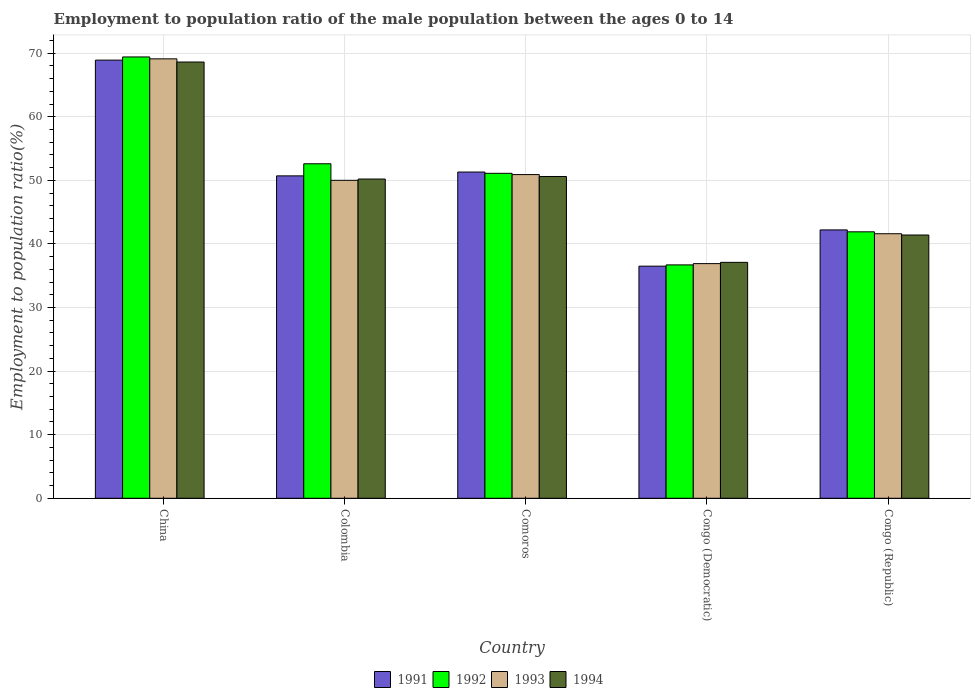How many different coloured bars are there?
Make the answer very short. 4. Are the number of bars on each tick of the X-axis equal?
Your answer should be very brief. Yes. How many bars are there on the 4th tick from the right?
Give a very brief answer. 4. What is the label of the 2nd group of bars from the left?
Make the answer very short. Colombia. In how many cases, is the number of bars for a given country not equal to the number of legend labels?
Offer a terse response. 0. What is the employment to population ratio in 1994 in China?
Give a very brief answer. 68.6. Across all countries, what is the maximum employment to population ratio in 1992?
Offer a terse response. 69.4. Across all countries, what is the minimum employment to population ratio in 1991?
Your response must be concise. 36.5. In which country was the employment to population ratio in 1992 maximum?
Keep it short and to the point. China. In which country was the employment to population ratio in 1994 minimum?
Your answer should be compact. Congo (Democratic). What is the total employment to population ratio in 1993 in the graph?
Offer a terse response. 248.5. What is the difference between the employment to population ratio in 1993 in Congo (Democratic) and that in Congo (Republic)?
Your response must be concise. -4.7. What is the average employment to population ratio in 1992 per country?
Provide a short and direct response. 50.34. What is the difference between the employment to population ratio of/in 1994 and employment to population ratio of/in 1992 in China?
Your answer should be compact. -0.8. In how many countries, is the employment to population ratio in 1993 greater than 46 %?
Your answer should be very brief. 3. What is the ratio of the employment to population ratio in 1993 in Congo (Democratic) to that in Congo (Republic)?
Give a very brief answer. 0.89. What is the difference between the highest and the second highest employment to population ratio in 1992?
Give a very brief answer. -1.5. What is the difference between the highest and the lowest employment to population ratio in 1992?
Provide a succinct answer. 32.7. In how many countries, is the employment to population ratio in 1991 greater than the average employment to population ratio in 1991 taken over all countries?
Offer a very short reply. 3. Is it the case that in every country, the sum of the employment to population ratio in 1994 and employment to population ratio in 1992 is greater than the employment to population ratio in 1993?
Your answer should be very brief. Yes. How many bars are there?
Offer a terse response. 20. What is the difference between two consecutive major ticks on the Y-axis?
Make the answer very short. 10. Does the graph contain any zero values?
Give a very brief answer. No. Where does the legend appear in the graph?
Ensure brevity in your answer.  Bottom center. How are the legend labels stacked?
Offer a terse response. Horizontal. What is the title of the graph?
Provide a succinct answer. Employment to population ratio of the male population between the ages 0 to 14. Does "1962" appear as one of the legend labels in the graph?
Make the answer very short. No. What is the label or title of the X-axis?
Provide a succinct answer. Country. What is the label or title of the Y-axis?
Provide a succinct answer. Employment to population ratio(%). What is the Employment to population ratio(%) of 1991 in China?
Offer a very short reply. 68.9. What is the Employment to population ratio(%) of 1992 in China?
Your answer should be compact. 69.4. What is the Employment to population ratio(%) of 1993 in China?
Provide a short and direct response. 69.1. What is the Employment to population ratio(%) of 1994 in China?
Offer a very short reply. 68.6. What is the Employment to population ratio(%) in 1991 in Colombia?
Ensure brevity in your answer.  50.7. What is the Employment to population ratio(%) in 1992 in Colombia?
Your answer should be compact. 52.6. What is the Employment to population ratio(%) of 1993 in Colombia?
Give a very brief answer. 50. What is the Employment to population ratio(%) in 1994 in Colombia?
Offer a very short reply. 50.2. What is the Employment to population ratio(%) in 1991 in Comoros?
Your answer should be compact. 51.3. What is the Employment to population ratio(%) of 1992 in Comoros?
Your response must be concise. 51.1. What is the Employment to population ratio(%) in 1993 in Comoros?
Your answer should be compact. 50.9. What is the Employment to population ratio(%) in 1994 in Comoros?
Offer a very short reply. 50.6. What is the Employment to population ratio(%) of 1991 in Congo (Democratic)?
Offer a very short reply. 36.5. What is the Employment to population ratio(%) in 1992 in Congo (Democratic)?
Your response must be concise. 36.7. What is the Employment to population ratio(%) in 1993 in Congo (Democratic)?
Your response must be concise. 36.9. What is the Employment to population ratio(%) of 1994 in Congo (Democratic)?
Keep it short and to the point. 37.1. What is the Employment to population ratio(%) of 1991 in Congo (Republic)?
Provide a succinct answer. 42.2. What is the Employment to population ratio(%) of 1992 in Congo (Republic)?
Make the answer very short. 41.9. What is the Employment to population ratio(%) in 1993 in Congo (Republic)?
Ensure brevity in your answer.  41.6. What is the Employment to population ratio(%) of 1994 in Congo (Republic)?
Offer a terse response. 41.4. Across all countries, what is the maximum Employment to population ratio(%) of 1991?
Your response must be concise. 68.9. Across all countries, what is the maximum Employment to population ratio(%) in 1992?
Offer a terse response. 69.4. Across all countries, what is the maximum Employment to population ratio(%) in 1993?
Make the answer very short. 69.1. Across all countries, what is the maximum Employment to population ratio(%) of 1994?
Give a very brief answer. 68.6. Across all countries, what is the minimum Employment to population ratio(%) in 1991?
Provide a succinct answer. 36.5. Across all countries, what is the minimum Employment to population ratio(%) in 1992?
Your response must be concise. 36.7. Across all countries, what is the minimum Employment to population ratio(%) of 1993?
Provide a short and direct response. 36.9. Across all countries, what is the minimum Employment to population ratio(%) of 1994?
Offer a terse response. 37.1. What is the total Employment to population ratio(%) of 1991 in the graph?
Ensure brevity in your answer.  249.6. What is the total Employment to population ratio(%) in 1992 in the graph?
Provide a succinct answer. 251.7. What is the total Employment to population ratio(%) of 1993 in the graph?
Provide a succinct answer. 248.5. What is the total Employment to population ratio(%) in 1994 in the graph?
Your response must be concise. 247.9. What is the difference between the Employment to population ratio(%) in 1992 in China and that in Colombia?
Make the answer very short. 16.8. What is the difference between the Employment to population ratio(%) in 1993 in China and that in Colombia?
Keep it short and to the point. 19.1. What is the difference between the Employment to population ratio(%) in 1994 in China and that in Colombia?
Make the answer very short. 18.4. What is the difference between the Employment to population ratio(%) in 1992 in China and that in Comoros?
Your answer should be compact. 18.3. What is the difference between the Employment to population ratio(%) of 1993 in China and that in Comoros?
Your response must be concise. 18.2. What is the difference between the Employment to population ratio(%) in 1994 in China and that in Comoros?
Offer a terse response. 18. What is the difference between the Employment to population ratio(%) of 1991 in China and that in Congo (Democratic)?
Keep it short and to the point. 32.4. What is the difference between the Employment to population ratio(%) in 1992 in China and that in Congo (Democratic)?
Keep it short and to the point. 32.7. What is the difference between the Employment to population ratio(%) of 1993 in China and that in Congo (Democratic)?
Ensure brevity in your answer.  32.2. What is the difference between the Employment to population ratio(%) of 1994 in China and that in Congo (Democratic)?
Provide a short and direct response. 31.5. What is the difference between the Employment to population ratio(%) of 1991 in China and that in Congo (Republic)?
Provide a short and direct response. 26.7. What is the difference between the Employment to population ratio(%) in 1992 in China and that in Congo (Republic)?
Make the answer very short. 27.5. What is the difference between the Employment to population ratio(%) of 1993 in China and that in Congo (Republic)?
Offer a terse response. 27.5. What is the difference between the Employment to population ratio(%) in 1994 in China and that in Congo (Republic)?
Offer a very short reply. 27.2. What is the difference between the Employment to population ratio(%) of 1991 in Colombia and that in Comoros?
Make the answer very short. -0.6. What is the difference between the Employment to population ratio(%) in 1992 in Colombia and that in Comoros?
Offer a very short reply. 1.5. What is the difference between the Employment to population ratio(%) in 1994 in Colombia and that in Comoros?
Your answer should be compact. -0.4. What is the difference between the Employment to population ratio(%) in 1991 in Colombia and that in Congo (Democratic)?
Your answer should be very brief. 14.2. What is the difference between the Employment to population ratio(%) of 1992 in Colombia and that in Congo (Democratic)?
Ensure brevity in your answer.  15.9. What is the difference between the Employment to population ratio(%) of 1993 in Colombia and that in Congo (Democratic)?
Offer a terse response. 13.1. What is the difference between the Employment to population ratio(%) in 1994 in Colombia and that in Congo (Democratic)?
Provide a short and direct response. 13.1. What is the difference between the Employment to population ratio(%) of 1994 in Colombia and that in Congo (Republic)?
Offer a very short reply. 8.8. What is the difference between the Employment to population ratio(%) of 1993 in Comoros and that in Congo (Democratic)?
Your answer should be compact. 14. What is the difference between the Employment to population ratio(%) in 1994 in Comoros and that in Congo (Democratic)?
Your answer should be compact. 13.5. What is the difference between the Employment to population ratio(%) in 1993 in Comoros and that in Congo (Republic)?
Offer a very short reply. 9.3. What is the difference between the Employment to population ratio(%) of 1991 in Congo (Democratic) and that in Congo (Republic)?
Make the answer very short. -5.7. What is the difference between the Employment to population ratio(%) in 1992 in Congo (Democratic) and that in Congo (Republic)?
Give a very brief answer. -5.2. What is the difference between the Employment to population ratio(%) of 1994 in Congo (Democratic) and that in Congo (Republic)?
Keep it short and to the point. -4.3. What is the difference between the Employment to population ratio(%) of 1991 in China and the Employment to population ratio(%) of 1992 in Colombia?
Offer a terse response. 16.3. What is the difference between the Employment to population ratio(%) of 1991 in China and the Employment to population ratio(%) of 1994 in Colombia?
Ensure brevity in your answer.  18.7. What is the difference between the Employment to population ratio(%) in 1991 in China and the Employment to population ratio(%) in 1993 in Comoros?
Provide a succinct answer. 18. What is the difference between the Employment to population ratio(%) of 1991 in China and the Employment to population ratio(%) of 1994 in Comoros?
Your answer should be compact. 18.3. What is the difference between the Employment to population ratio(%) in 1992 in China and the Employment to population ratio(%) in 1994 in Comoros?
Your response must be concise. 18.8. What is the difference between the Employment to population ratio(%) of 1991 in China and the Employment to population ratio(%) of 1992 in Congo (Democratic)?
Keep it short and to the point. 32.2. What is the difference between the Employment to population ratio(%) in 1991 in China and the Employment to population ratio(%) in 1994 in Congo (Democratic)?
Your answer should be very brief. 31.8. What is the difference between the Employment to population ratio(%) in 1992 in China and the Employment to population ratio(%) in 1993 in Congo (Democratic)?
Your answer should be very brief. 32.5. What is the difference between the Employment to population ratio(%) of 1992 in China and the Employment to population ratio(%) of 1994 in Congo (Democratic)?
Your answer should be very brief. 32.3. What is the difference between the Employment to population ratio(%) in 1993 in China and the Employment to population ratio(%) in 1994 in Congo (Democratic)?
Ensure brevity in your answer.  32. What is the difference between the Employment to population ratio(%) of 1991 in China and the Employment to population ratio(%) of 1993 in Congo (Republic)?
Give a very brief answer. 27.3. What is the difference between the Employment to population ratio(%) in 1992 in China and the Employment to population ratio(%) in 1993 in Congo (Republic)?
Provide a succinct answer. 27.8. What is the difference between the Employment to population ratio(%) in 1992 in China and the Employment to population ratio(%) in 1994 in Congo (Republic)?
Provide a short and direct response. 28. What is the difference between the Employment to population ratio(%) in 1993 in China and the Employment to population ratio(%) in 1994 in Congo (Republic)?
Your response must be concise. 27.7. What is the difference between the Employment to population ratio(%) in 1991 in Colombia and the Employment to population ratio(%) in 1993 in Comoros?
Offer a terse response. -0.2. What is the difference between the Employment to population ratio(%) in 1991 in Colombia and the Employment to population ratio(%) in 1994 in Comoros?
Keep it short and to the point. 0.1. What is the difference between the Employment to population ratio(%) of 1993 in Colombia and the Employment to population ratio(%) of 1994 in Comoros?
Ensure brevity in your answer.  -0.6. What is the difference between the Employment to population ratio(%) in 1991 in Colombia and the Employment to population ratio(%) in 1993 in Congo (Republic)?
Your answer should be very brief. 9.1. What is the difference between the Employment to population ratio(%) in 1991 in Colombia and the Employment to population ratio(%) in 1994 in Congo (Republic)?
Give a very brief answer. 9.3. What is the difference between the Employment to population ratio(%) of 1992 in Colombia and the Employment to population ratio(%) of 1993 in Congo (Republic)?
Your answer should be very brief. 11. What is the difference between the Employment to population ratio(%) of 1992 in Colombia and the Employment to population ratio(%) of 1994 in Congo (Republic)?
Ensure brevity in your answer.  11.2. What is the difference between the Employment to population ratio(%) in 1991 in Comoros and the Employment to population ratio(%) in 1992 in Congo (Democratic)?
Keep it short and to the point. 14.6. What is the difference between the Employment to population ratio(%) in 1991 in Comoros and the Employment to population ratio(%) in 1993 in Congo (Democratic)?
Give a very brief answer. 14.4. What is the difference between the Employment to population ratio(%) in 1992 in Comoros and the Employment to population ratio(%) in 1993 in Congo (Democratic)?
Your answer should be compact. 14.2. What is the difference between the Employment to population ratio(%) in 1992 in Comoros and the Employment to population ratio(%) in 1994 in Congo (Democratic)?
Provide a short and direct response. 14. What is the difference between the Employment to population ratio(%) of 1991 in Comoros and the Employment to population ratio(%) of 1992 in Congo (Republic)?
Keep it short and to the point. 9.4. What is the difference between the Employment to population ratio(%) of 1992 in Comoros and the Employment to population ratio(%) of 1993 in Congo (Republic)?
Ensure brevity in your answer.  9.5. What is the difference between the Employment to population ratio(%) in 1993 in Comoros and the Employment to population ratio(%) in 1994 in Congo (Republic)?
Your answer should be very brief. 9.5. What is the average Employment to population ratio(%) of 1991 per country?
Provide a succinct answer. 49.92. What is the average Employment to population ratio(%) of 1992 per country?
Provide a succinct answer. 50.34. What is the average Employment to population ratio(%) of 1993 per country?
Offer a very short reply. 49.7. What is the average Employment to population ratio(%) of 1994 per country?
Offer a terse response. 49.58. What is the difference between the Employment to population ratio(%) of 1991 and Employment to population ratio(%) of 1992 in China?
Offer a very short reply. -0.5. What is the difference between the Employment to population ratio(%) of 1991 and Employment to population ratio(%) of 1994 in China?
Offer a very short reply. 0.3. What is the difference between the Employment to population ratio(%) in 1993 and Employment to population ratio(%) in 1994 in China?
Offer a terse response. 0.5. What is the difference between the Employment to population ratio(%) in 1991 and Employment to population ratio(%) in 1992 in Colombia?
Your answer should be compact. -1.9. What is the difference between the Employment to population ratio(%) in 1991 and Employment to population ratio(%) in 1993 in Colombia?
Your answer should be very brief. 0.7. What is the difference between the Employment to population ratio(%) in 1992 and Employment to population ratio(%) in 1993 in Colombia?
Offer a very short reply. 2.6. What is the difference between the Employment to population ratio(%) of 1992 and Employment to population ratio(%) of 1994 in Colombia?
Make the answer very short. 2.4. What is the difference between the Employment to population ratio(%) in 1993 and Employment to population ratio(%) in 1994 in Colombia?
Give a very brief answer. -0.2. What is the difference between the Employment to population ratio(%) in 1991 and Employment to population ratio(%) in 1992 in Comoros?
Your answer should be very brief. 0.2. What is the difference between the Employment to population ratio(%) of 1991 and Employment to population ratio(%) of 1993 in Comoros?
Your answer should be compact. 0.4. What is the difference between the Employment to population ratio(%) in 1992 and Employment to population ratio(%) in 1993 in Comoros?
Provide a short and direct response. 0.2. What is the difference between the Employment to population ratio(%) in 1992 and Employment to population ratio(%) in 1994 in Comoros?
Provide a succinct answer. 0.5. What is the difference between the Employment to population ratio(%) of 1991 and Employment to population ratio(%) of 1993 in Congo (Democratic)?
Your answer should be compact. -0.4. What is the difference between the Employment to population ratio(%) of 1993 and Employment to population ratio(%) of 1994 in Congo (Democratic)?
Your answer should be compact. -0.2. What is the difference between the Employment to population ratio(%) in 1993 and Employment to population ratio(%) in 1994 in Congo (Republic)?
Your answer should be compact. 0.2. What is the ratio of the Employment to population ratio(%) in 1991 in China to that in Colombia?
Keep it short and to the point. 1.36. What is the ratio of the Employment to population ratio(%) of 1992 in China to that in Colombia?
Keep it short and to the point. 1.32. What is the ratio of the Employment to population ratio(%) in 1993 in China to that in Colombia?
Your response must be concise. 1.38. What is the ratio of the Employment to population ratio(%) of 1994 in China to that in Colombia?
Your response must be concise. 1.37. What is the ratio of the Employment to population ratio(%) in 1991 in China to that in Comoros?
Ensure brevity in your answer.  1.34. What is the ratio of the Employment to population ratio(%) of 1992 in China to that in Comoros?
Provide a short and direct response. 1.36. What is the ratio of the Employment to population ratio(%) of 1993 in China to that in Comoros?
Offer a terse response. 1.36. What is the ratio of the Employment to population ratio(%) in 1994 in China to that in Comoros?
Give a very brief answer. 1.36. What is the ratio of the Employment to population ratio(%) in 1991 in China to that in Congo (Democratic)?
Give a very brief answer. 1.89. What is the ratio of the Employment to population ratio(%) of 1992 in China to that in Congo (Democratic)?
Your answer should be compact. 1.89. What is the ratio of the Employment to population ratio(%) in 1993 in China to that in Congo (Democratic)?
Keep it short and to the point. 1.87. What is the ratio of the Employment to population ratio(%) of 1994 in China to that in Congo (Democratic)?
Offer a very short reply. 1.85. What is the ratio of the Employment to population ratio(%) of 1991 in China to that in Congo (Republic)?
Make the answer very short. 1.63. What is the ratio of the Employment to population ratio(%) of 1992 in China to that in Congo (Republic)?
Your response must be concise. 1.66. What is the ratio of the Employment to population ratio(%) in 1993 in China to that in Congo (Republic)?
Offer a terse response. 1.66. What is the ratio of the Employment to population ratio(%) in 1994 in China to that in Congo (Republic)?
Provide a short and direct response. 1.66. What is the ratio of the Employment to population ratio(%) of 1991 in Colombia to that in Comoros?
Provide a short and direct response. 0.99. What is the ratio of the Employment to population ratio(%) in 1992 in Colombia to that in Comoros?
Offer a terse response. 1.03. What is the ratio of the Employment to population ratio(%) of 1993 in Colombia to that in Comoros?
Offer a terse response. 0.98. What is the ratio of the Employment to population ratio(%) in 1991 in Colombia to that in Congo (Democratic)?
Your response must be concise. 1.39. What is the ratio of the Employment to population ratio(%) of 1992 in Colombia to that in Congo (Democratic)?
Provide a succinct answer. 1.43. What is the ratio of the Employment to population ratio(%) of 1993 in Colombia to that in Congo (Democratic)?
Keep it short and to the point. 1.35. What is the ratio of the Employment to population ratio(%) in 1994 in Colombia to that in Congo (Democratic)?
Make the answer very short. 1.35. What is the ratio of the Employment to population ratio(%) in 1991 in Colombia to that in Congo (Republic)?
Provide a short and direct response. 1.2. What is the ratio of the Employment to population ratio(%) in 1992 in Colombia to that in Congo (Republic)?
Ensure brevity in your answer.  1.26. What is the ratio of the Employment to population ratio(%) in 1993 in Colombia to that in Congo (Republic)?
Make the answer very short. 1.2. What is the ratio of the Employment to population ratio(%) in 1994 in Colombia to that in Congo (Republic)?
Your response must be concise. 1.21. What is the ratio of the Employment to population ratio(%) of 1991 in Comoros to that in Congo (Democratic)?
Keep it short and to the point. 1.41. What is the ratio of the Employment to population ratio(%) of 1992 in Comoros to that in Congo (Democratic)?
Give a very brief answer. 1.39. What is the ratio of the Employment to population ratio(%) of 1993 in Comoros to that in Congo (Democratic)?
Your answer should be very brief. 1.38. What is the ratio of the Employment to population ratio(%) of 1994 in Comoros to that in Congo (Democratic)?
Provide a succinct answer. 1.36. What is the ratio of the Employment to population ratio(%) in 1991 in Comoros to that in Congo (Republic)?
Your answer should be very brief. 1.22. What is the ratio of the Employment to population ratio(%) in 1992 in Comoros to that in Congo (Republic)?
Offer a terse response. 1.22. What is the ratio of the Employment to population ratio(%) in 1993 in Comoros to that in Congo (Republic)?
Offer a terse response. 1.22. What is the ratio of the Employment to population ratio(%) of 1994 in Comoros to that in Congo (Republic)?
Provide a short and direct response. 1.22. What is the ratio of the Employment to population ratio(%) in 1991 in Congo (Democratic) to that in Congo (Republic)?
Your response must be concise. 0.86. What is the ratio of the Employment to population ratio(%) of 1992 in Congo (Democratic) to that in Congo (Republic)?
Offer a very short reply. 0.88. What is the ratio of the Employment to population ratio(%) in 1993 in Congo (Democratic) to that in Congo (Republic)?
Your response must be concise. 0.89. What is the ratio of the Employment to population ratio(%) in 1994 in Congo (Democratic) to that in Congo (Republic)?
Keep it short and to the point. 0.9. What is the difference between the highest and the second highest Employment to population ratio(%) in 1991?
Offer a terse response. 17.6. What is the difference between the highest and the second highest Employment to population ratio(%) in 1992?
Make the answer very short. 16.8. What is the difference between the highest and the lowest Employment to population ratio(%) in 1991?
Provide a short and direct response. 32.4. What is the difference between the highest and the lowest Employment to population ratio(%) of 1992?
Offer a terse response. 32.7. What is the difference between the highest and the lowest Employment to population ratio(%) of 1993?
Offer a very short reply. 32.2. What is the difference between the highest and the lowest Employment to population ratio(%) of 1994?
Ensure brevity in your answer.  31.5. 